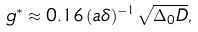<formula> <loc_0><loc_0><loc_500><loc_500>g ^ { \ast } \approx 0 . 1 6 \, ( a \delta ) ^ { - 1 } \sqrt { \Delta _ { 0 } D } ,</formula> 